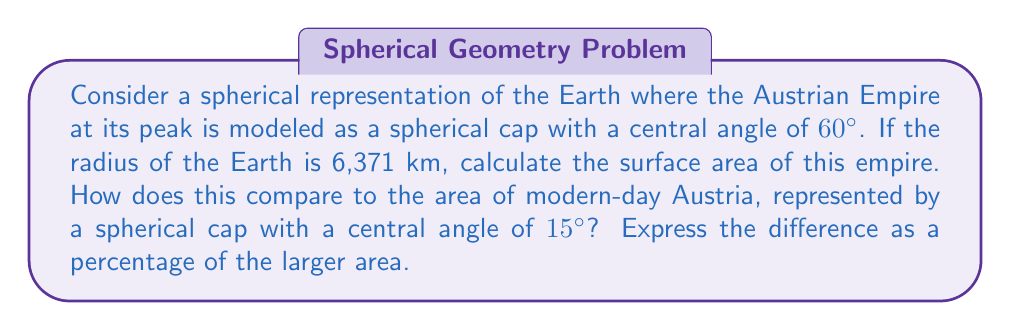Show me your answer to this math problem. Let's approach this step-by-step:

1) The formula for the surface area of a spherical cap is:
   $$A = 2\pi R^2(1-\cos\theta)$$
   where $R$ is the radius of the sphere and $\theta$ is the central angle in radians.

2) Convert the angles from degrees to radians:
   For the Empire: $60° = \frac{\pi}{3}$ radians
   For modern Austria: $15° = \frac{\pi}{12}$ radians

3) Calculate the area of the Austrian Empire:
   $$A_1 = 2\pi (6371)^2(1-\cos\frac{\pi}{3})$$
   $$= 2\pi (40589641)(1-0.5)$$
   $$= 127,420,000 \text{ km}^2$$

4) Calculate the area of modern Austria:
   $$A_2 = 2\pi (6371)^2(1-\cos\frac{\pi}{12})$$
   $$= 2\pi (40589641)(1-0.9659)$$
   $$= 8,660,000 \text{ km}^2$$

5) Calculate the difference:
   $$\text{Difference} = A_1 - A_2 = 118,760,000 \text{ km}^2$$

6) Express the difference as a percentage of the larger area:
   $$\text{Percentage} = \frac{\text{Difference}}{A_1} \times 100\%$$
   $$= \frac{118,760,000}{127,420,000} \times 100\% = 93.2\%$$
Answer: 93.2% 